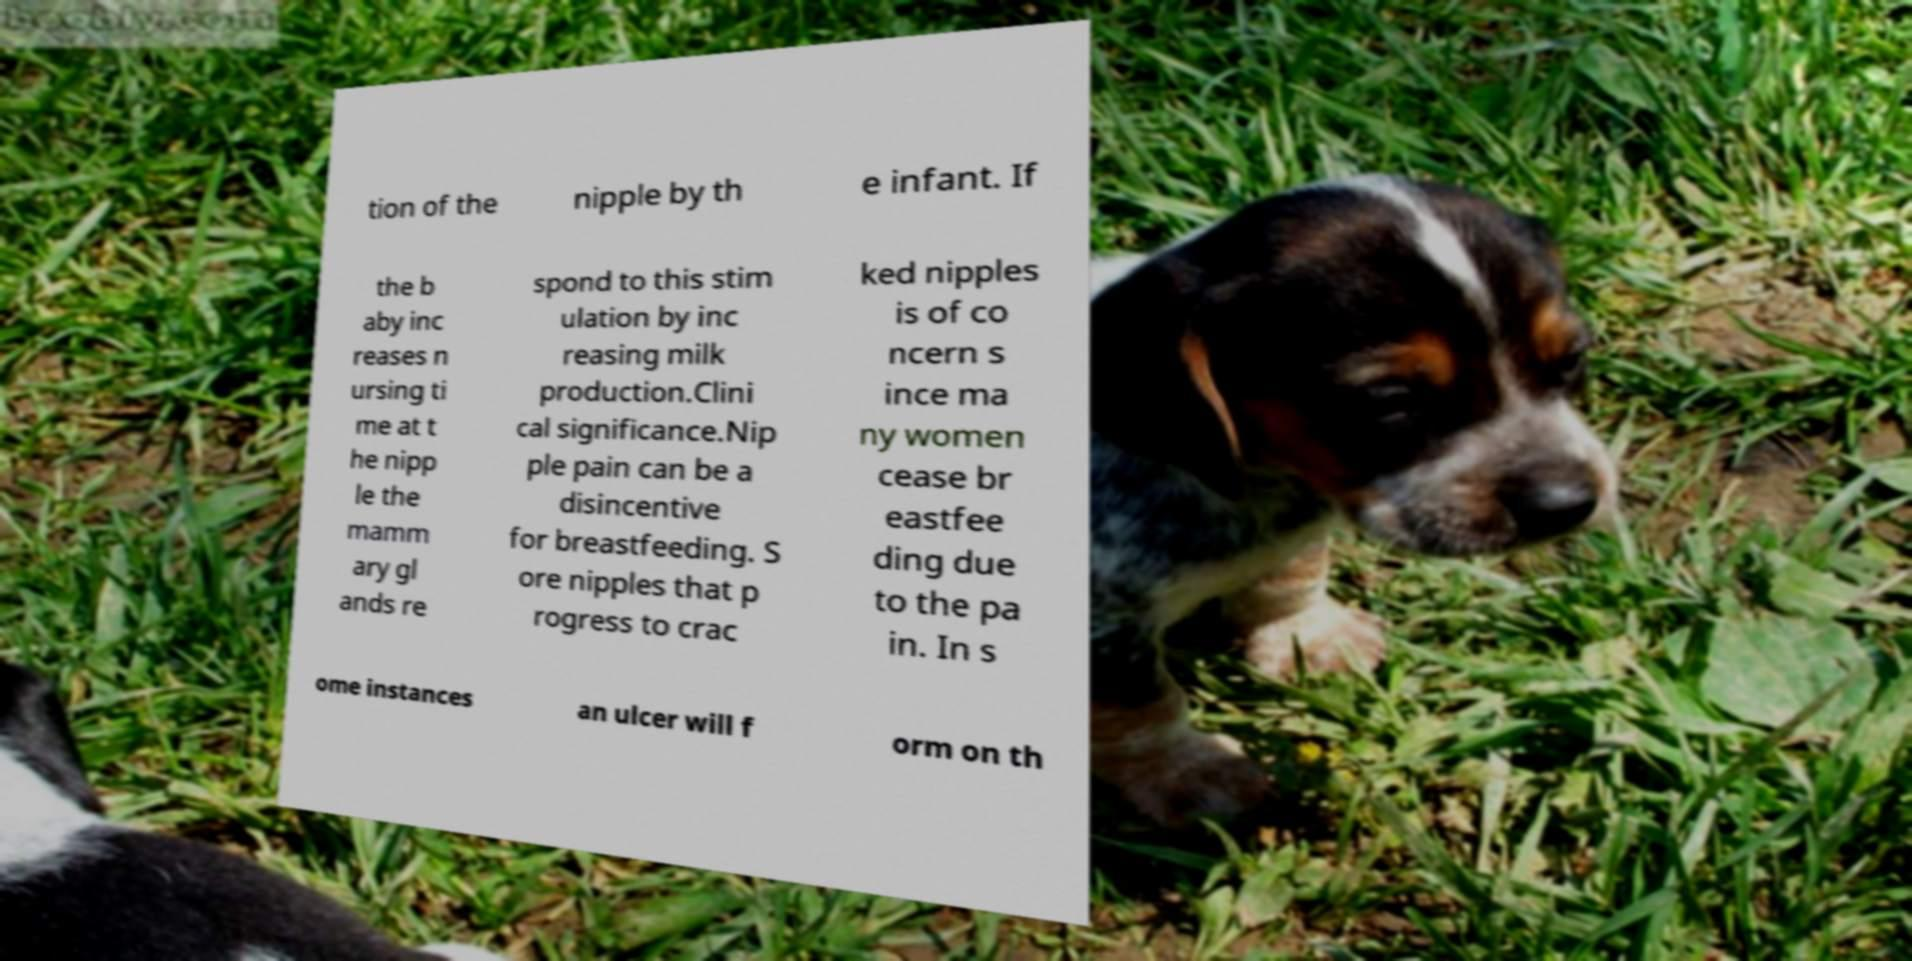Could you extract and type out the text from this image? tion of the nipple by th e infant. If the b aby inc reases n ursing ti me at t he nipp le the mamm ary gl ands re spond to this stim ulation by inc reasing milk production.Clini cal significance.Nip ple pain can be a disincentive for breastfeeding. S ore nipples that p rogress to crac ked nipples is of co ncern s ince ma ny women cease br eastfee ding due to the pa in. In s ome instances an ulcer will f orm on th 